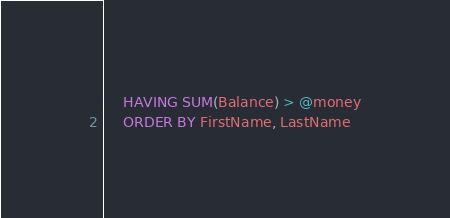<code> <loc_0><loc_0><loc_500><loc_500><_SQL_>	HAVING SUM(Balance) > @money
	ORDER BY FirstName, LastName</code> 